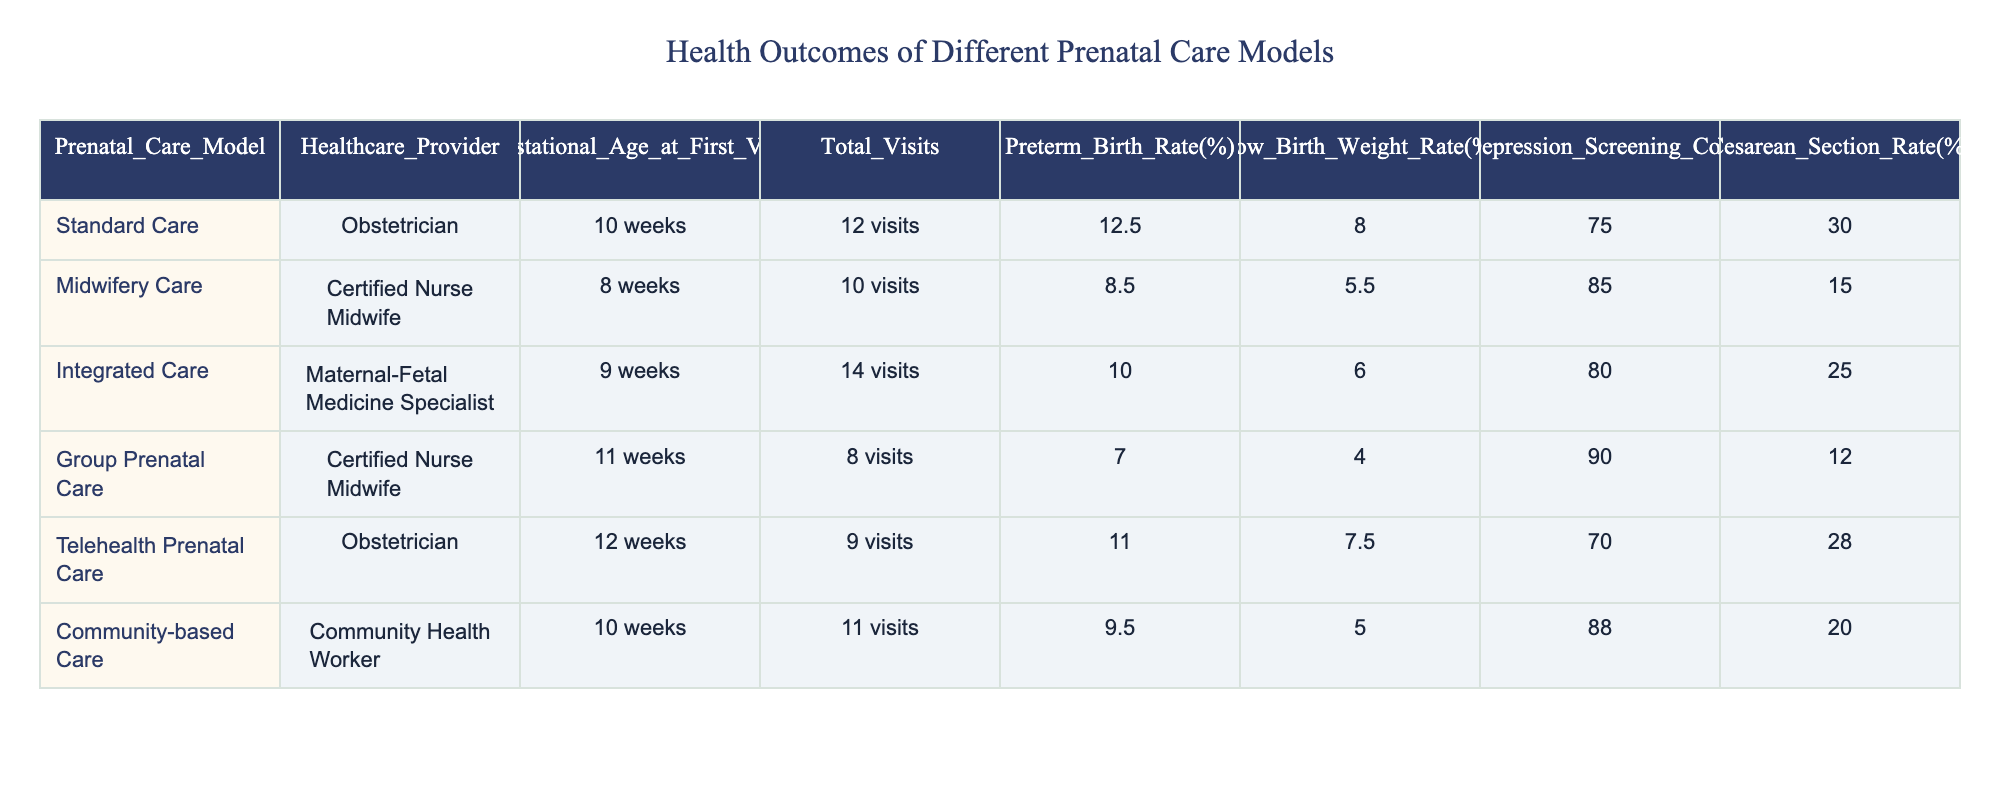What is the preterm birth rate for Midwifery Care? The preterm birth rate for Midwifery Care is listed in the table under that model, which shows a value of 8.5%.
Answer: 8.5% How many total visits does Group Prenatal Care provide? The table indicates that Group Prenatal Care has a total of 8 visits.
Answer: 8 visits Which prenatal care model has the lowest low birth weight rate? By comparing the low birth weight rates across all models in the table, Group Prenatal Care has the lowest rate at 4.0%.
Answer: 4.0% What is the average number of total visits among all prenatal care models? To find the average number of visits, add all the total visits: 12 + 10 + 14 + 8 + 9 + 11 = 64. There are 6 models, so the average is 64 / 6 = 10.67.
Answer: 10.67 Is the maternal depression screening completion rate for Community-based Care over 80%? The table shows that the maternal depression screening completion rate for Community-based Care is 88%, which is indeed over 80%.
Answer: Yes How does the cesarean section rate of Integrated Care compare to that of Midwifery Care? The cesarean section rate for Integrated Care is 25%, while Midwifery Care is 15%. Since 25% is greater than 15%, Integrated Care has a higher rate.
Answer: Higher Which prenatal care model has the highest maternal depression screening completion rate? Reviewing the table, Group Prenatal Care has the highest completion rate at 90%.
Answer: 90% If we exclude Group Prenatal Care, what is the average preterm birth rate for the other models? Summing the preterm birth rates excluding Group Prenatal Care: 12.5 + 8.5 + 10.0 + 11.0 + 9.5 = 51.5. There are 5 models, so the average is 51.5 / 5 = 10.3.
Answer: 10.3 Is the gestational age at the first visit for Telehealth Prenatal Care later than that for Standard Care? The table shows that Telehealth Prenatal Care starts at 12 weeks and Standard Care starts at 10 weeks, meaning Telehealth Prenatal Care begins later.
Answer: Yes 